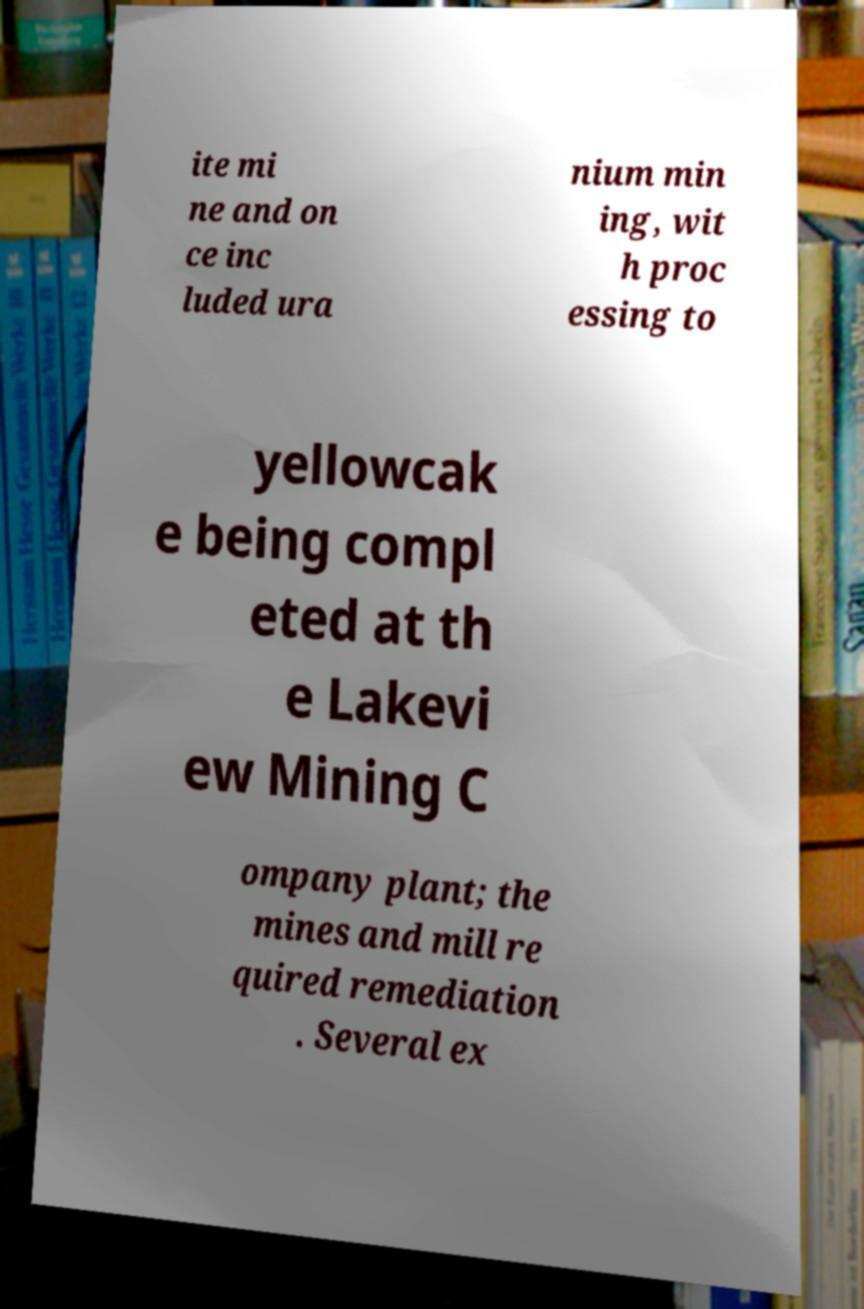Could you extract and type out the text from this image? ite mi ne and on ce inc luded ura nium min ing, wit h proc essing to yellowcak e being compl eted at th e Lakevi ew Mining C ompany plant; the mines and mill re quired remediation . Several ex 